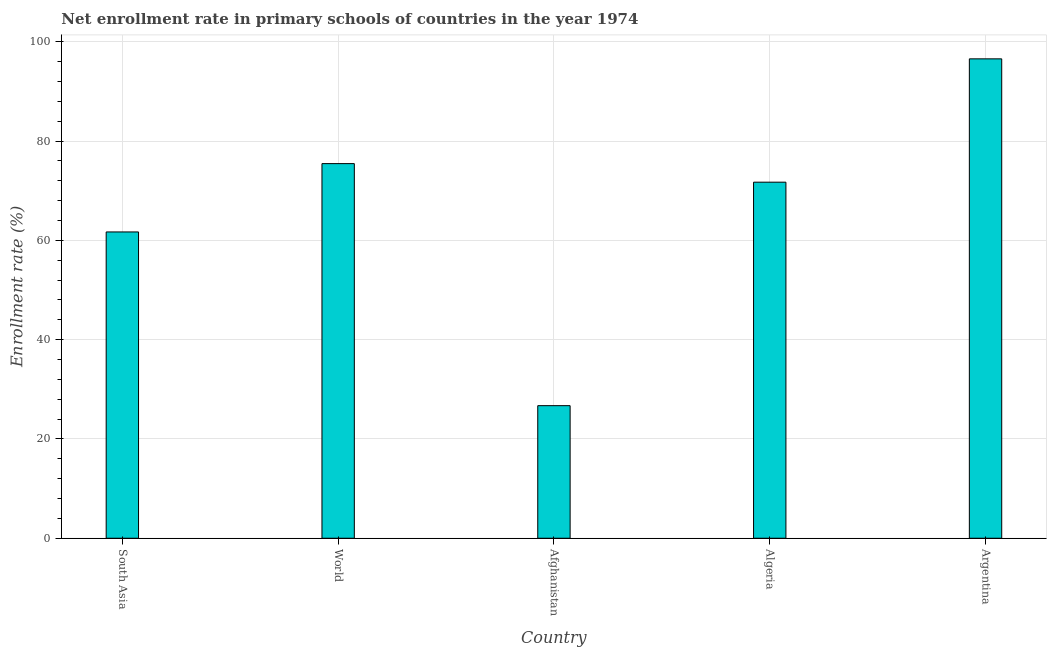Does the graph contain any zero values?
Keep it short and to the point. No. Does the graph contain grids?
Provide a succinct answer. Yes. What is the title of the graph?
Make the answer very short. Net enrollment rate in primary schools of countries in the year 1974. What is the label or title of the Y-axis?
Ensure brevity in your answer.  Enrollment rate (%). What is the net enrollment rate in primary schools in Afghanistan?
Offer a terse response. 26.7. Across all countries, what is the maximum net enrollment rate in primary schools?
Offer a very short reply. 96.55. Across all countries, what is the minimum net enrollment rate in primary schools?
Your answer should be compact. 26.7. In which country was the net enrollment rate in primary schools maximum?
Your answer should be compact. Argentina. In which country was the net enrollment rate in primary schools minimum?
Keep it short and to the point. Afghanistan. What is the sum of the net enrollment rate in primary schools?
Offer a very short reply. 332.1. What is the difference between the net enrollment rate in primary schools in Algeria and World?
Offer a terse response. -3.74. What is the average net enrollment rate in primary schools per country?
Your response must be concise. 66.42. What is the median net enrollment rate in primary schools?
Provide a short and direct response. 71.71. What is the ratio of the net enrollment rate in primary schools in South Asia to that in World?
Your response must be concise. 0.82. Is the net enrollment rate in primary schools in Argentina less than that in South Asia?
Provide a short and direct response. No. Is the difference between the net enrollment rate in primary schools in South Asia and World greater than the difference between any two countries?
Make the answer very short. No. What is the difference between the highest and the second highest net enrollment rate in primary schools?
Your answer should be very brief. 21.1. What is the difference between the highest and the lowest net enrollment rate in primary schools?
Provide a short and direct response. 69.85. In how many countries, is the net enrollment rate in primary schools greater than the average net enrollment rate in primary schools taken over all countries?
Keep it short and to the point. 3. Are the values on the major ticks of Y-axis written in scientific E-notation?
Offer a terse response. No. What is the Enrollment rate (%) of South Asia?
Provide a short and direct response. 61.69. What is the Enrollment rate (%) in World?
Your response must be concise. 75.45. What is the Enrollment rate (%) of Afghanistan?
Offer a very short reply. 26.7. What is the Enrollment rate (%) in Algeria?
Make the answer very short. 71.71. What is the Enrollment rate (%) in Argentina?
Your answer should be compact. 96.55. What is the difference between the Enrollment rate (%) in South Asia and World?
Your answer should be very brief. -13.76. What is the difference between the Enrollment rate (%) in South Asia and Afghanistan?
Offer a terse response. 34.99. What is the difference between the Enrollment rate (%) in South Asia and Algeria?
Give a very brief answer. -10.02. What is the difference between the Enrollment rate (%) in South Asia and Argentina?
Your answer should be compact. -34.86. What is the difference between the Enrollment rate (%) in World and Afghanistan?
Your answer should be compact. 48.75. What is the difference between the Enrollment rate (%) in World and Algeria?
Your answer should be compact. 3.74. What is the difference between the Enrollment rate (%) in World and Argentina?
Provide a short and direct response. -21.1. What is the difference between the Enrollment rate (%) in Afghanistan and Algeria?
Offer a very short reply. -45.01. What is the difference between the Enrollment rate (%) in Afghanistan and Argentina?
Keep it short and to the point. -69.85. What is the difference between the Enrollment rate (%) in Algeria and Argentina?
Ensure brevity in your answer.  -24.84. What is the ratio of the Enrollment rate (%) in South Asia to that in World?
Your answer should be very brief. 0.82. What is the ratio of the Enrollment rate (%) in South Asia to that in Afghanistan?
Provide a short and direct response. 2.31. What is the ratio of the Enrollment rate (%) in South Asia to that in Algeria?
Offer a very short reply. 0.86. What is the ratio of the Enrollment rate (%) in South Asia to that in Argentina?
Your answer should be compact. 0.64. What is the ratio of the Enrollment rate (%) in World to that in Afghanistan?
Provide a short and direct response. 2.83. What is the ratio of the Enrollment rate (%) in World to that in Algeria?
Your answer should be compact. 1.05. What is the ratio of the Enrollment rate (%) in World to that in Argentina?
Offer a very short reply. 0.78. What is the ratio of the Enrollment rate (%) in Afghanistan to that in Algeria?
Give a very brief answer. 0.37. What is the ratio of the Enrollment rate (%) in Afghanistan to that in Argentina?
Give a very brief answer. 0.28. What is the ratio of the Enrollment rate (%) in Algeria to that in Argentina?
Your response must be concise. 0.74. 